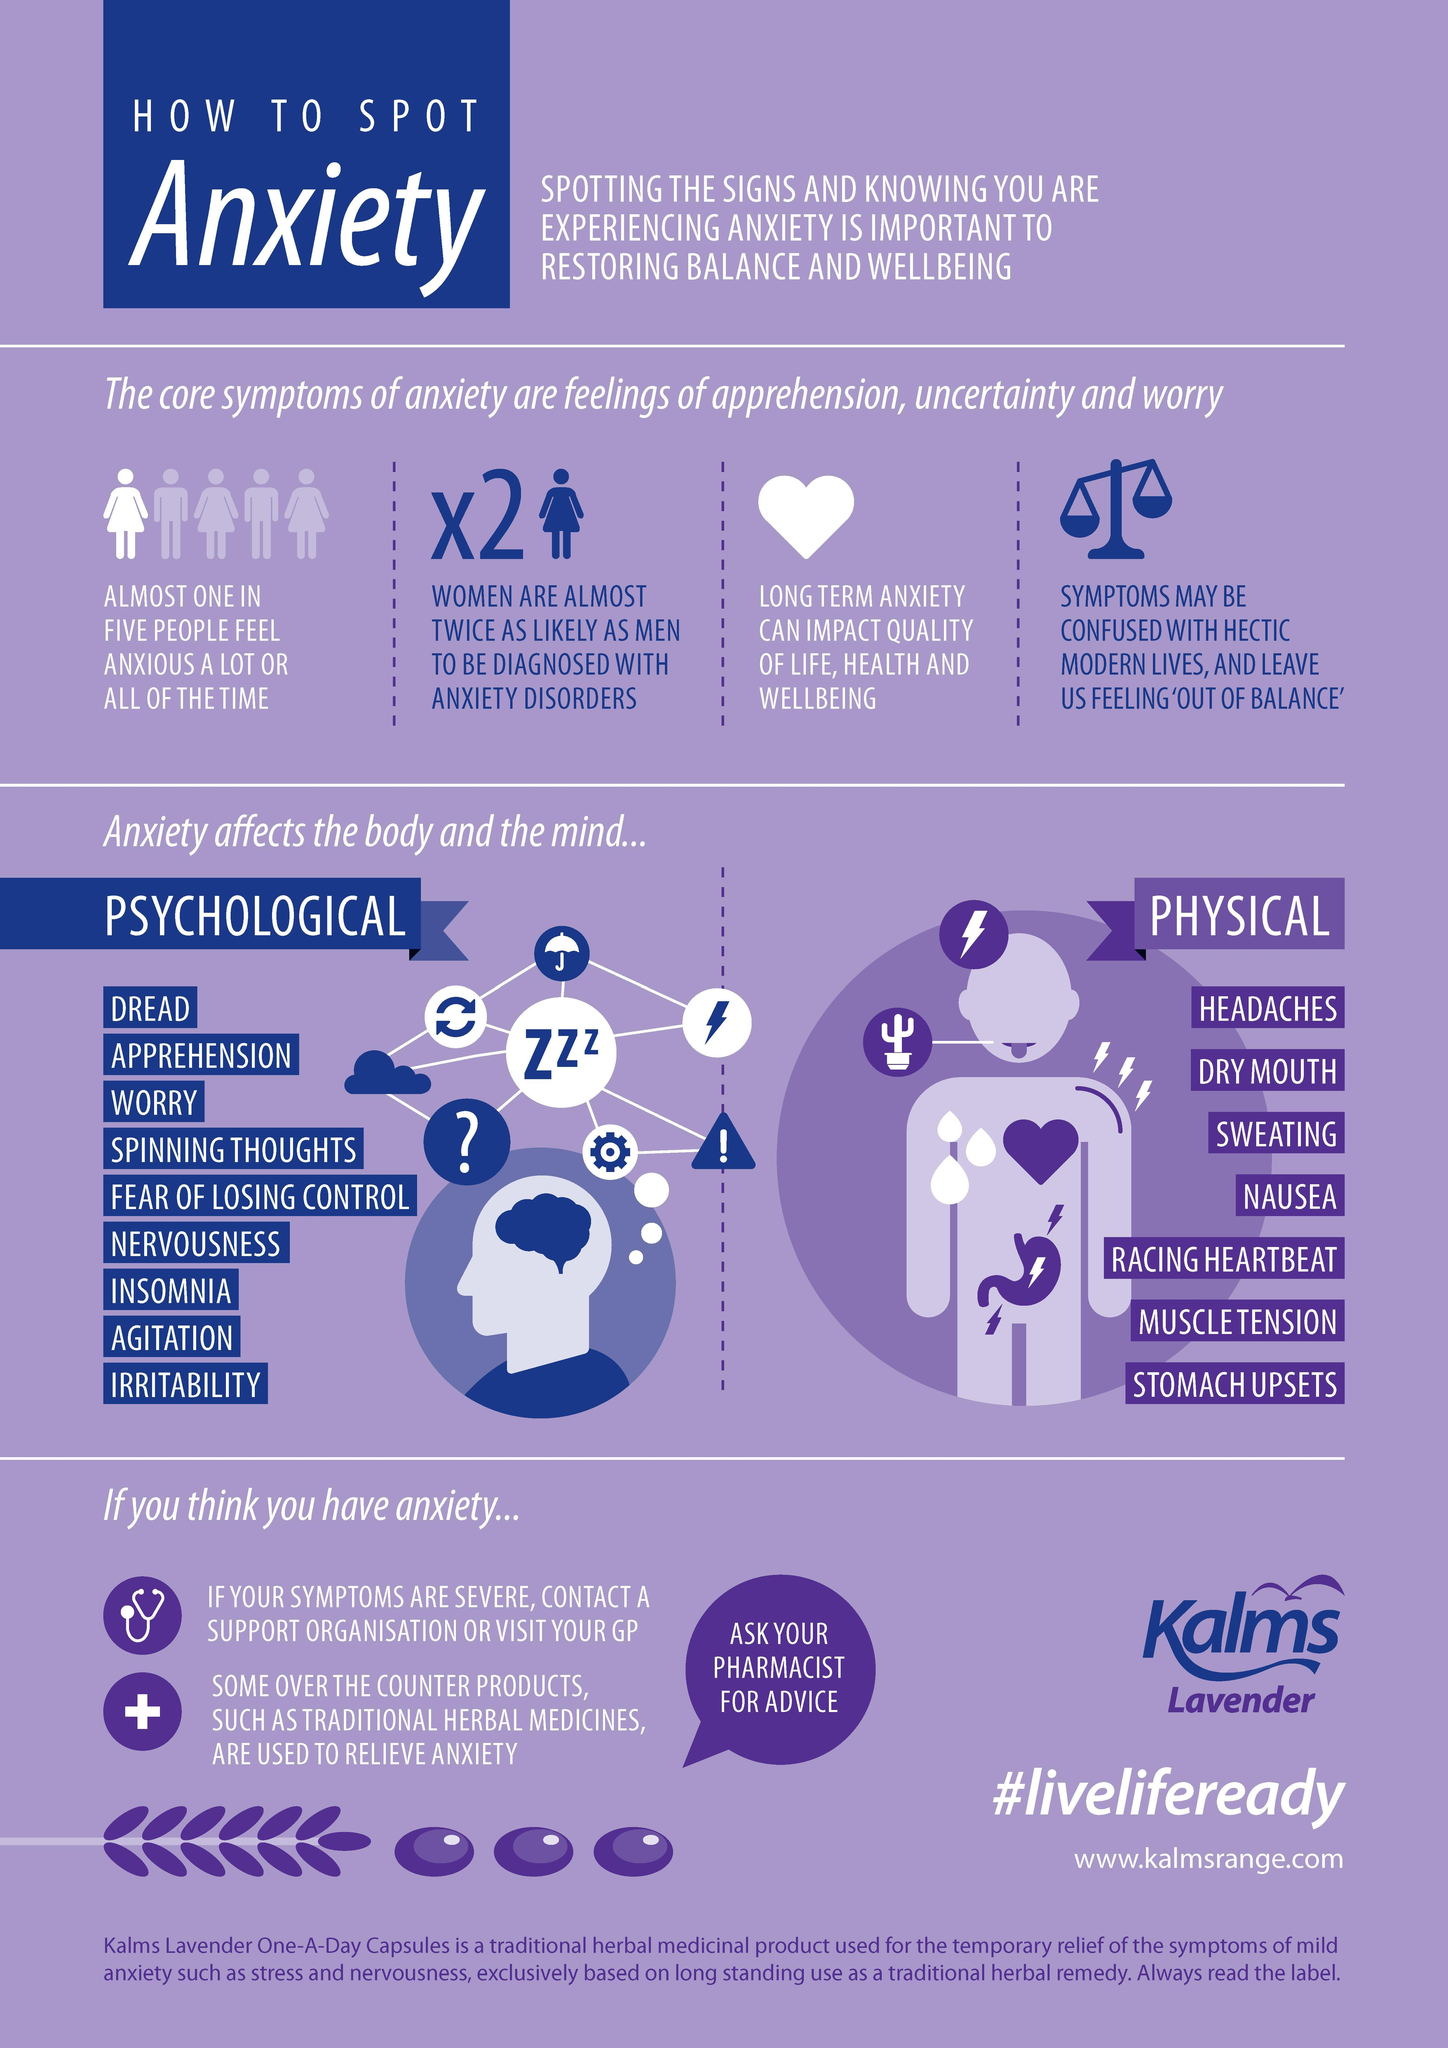How many psychological implications does anxiety cause?
Answer the question with a short phrase. 9 How many physical implications does anxiety cause ? 7 